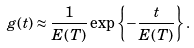<formula> <loc_0><loc_0><loc_500><loc_500>g ( t ) \approx \frac { 1 } { E ( T ) } \exp \left \{ - \frac { t } { E ( T ) } \right \} .</formula> 